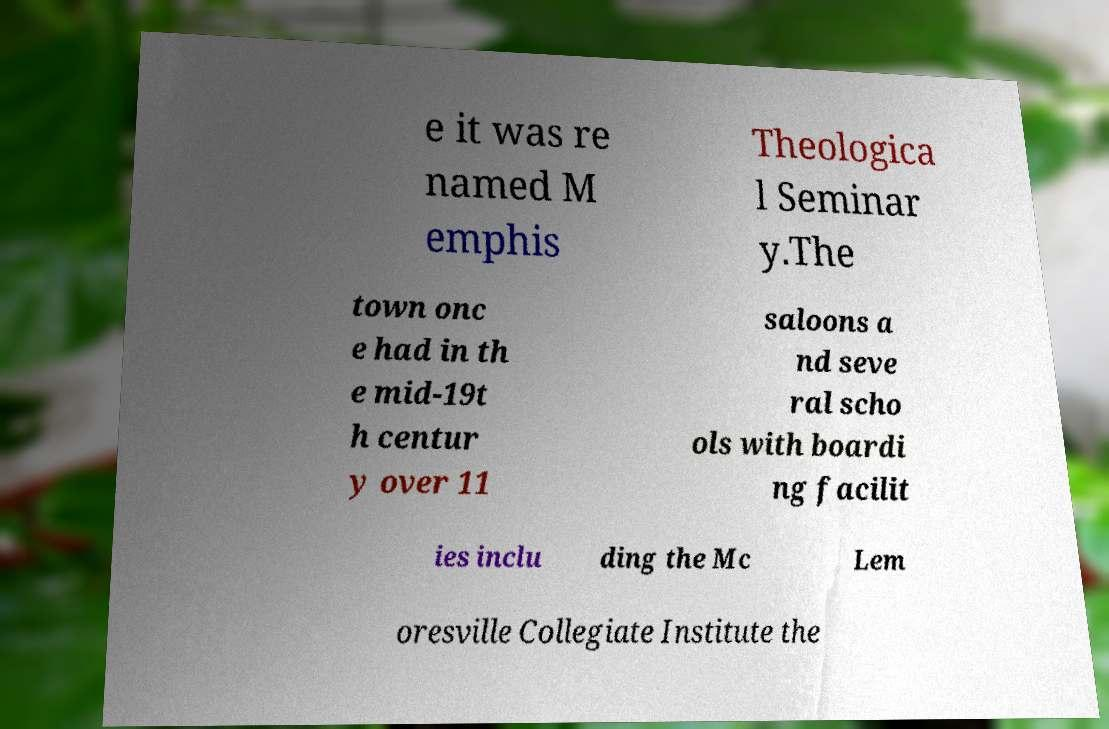Could you assist in decoding the text presented in this image and type it out clearly? e it was re named M emphis Theologica l Seminar y.The town onc e had in th e mid-19t h centur y over 11 saloons a nd seve ral scho ols with boardi ng facilit ies inclu ding the Mc Lem oresville Collegiate Institute the 